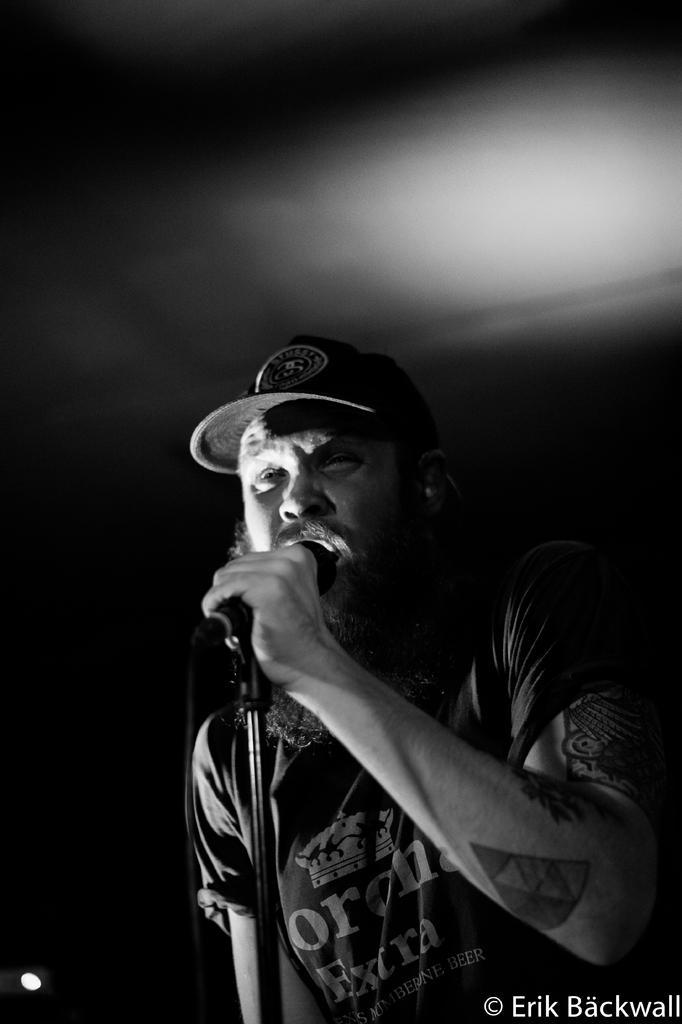Who is the main subject in the image? There is a man in the image. What is the man holding in his hand? The man is holding a microphone in his hand. What might the man be doing with the microphone? The man appears to be singing, as he is holding a microphone. What type of root can be seen growing in the dirt near the man in the image? There is no root or dirt present in the image; it features a man holding a microphone. What color is the silver object the man is holding in the image? The microphone is not described as being silver in the image, and there is no other silver object present. 